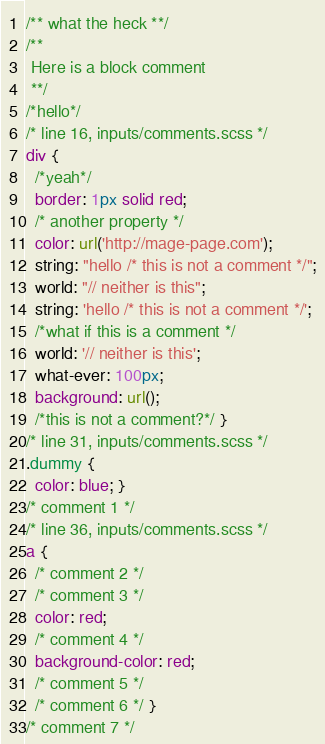<code> <loc_0><loc_0><loc_500><loc_500><_CSS_>/** what the heck **/
/**
 Here is a block comment
 **/
/*hello*/
/* line 16, inputs/comments.scss */
div {
  /*yeah*/
  border: 1px solid red;
  /* another property */
  color: url('http://mage-page.com');
  string: "hello /* this is not a comment */";
  world: "// neither is this";
  string: 'hello /* this is not a comment */';
  /*what if this is a comment */
  world: '// neither is this';
  what-ever: 100px;
  background: url();
  /*this is not a comment?*/ }
/* line 31, inputs/comments.scss */
.dummy {
  color: blue; }
/* comment 1 */
/* line 36, inputs/comments.scss */
a {
  /* comment 2 */
  /* comment 3 */
  color: red;
  /* comment 4 */
  background-color: red;
  /* comment 5 */
  /* comment 6 */ }
/* comment 7 */
</code> 